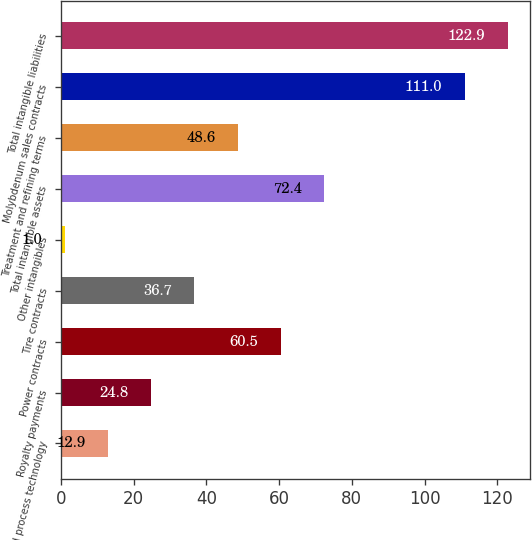Convert chart. <chart><loc_0><loc_0><loc_500><loc_500><bar_chart><fcel>Patents and process technology<fcel>Royalty payments<fcel>Power contracts<fcel>Tire contracts<fcel>Other intangibles<fcel>Total intangible assets<fcel>Treatment and refining terms<fcel>Molybdenum sales contracts<fcel>Total intangible liabilities<nl><fcel>12.9<fcel>24.8<fcel>60.5<fcel>36.7<fcel>1<fcel>72.4<fcel>48.6<fcel>111<fcel>122.9<nl></chart> 